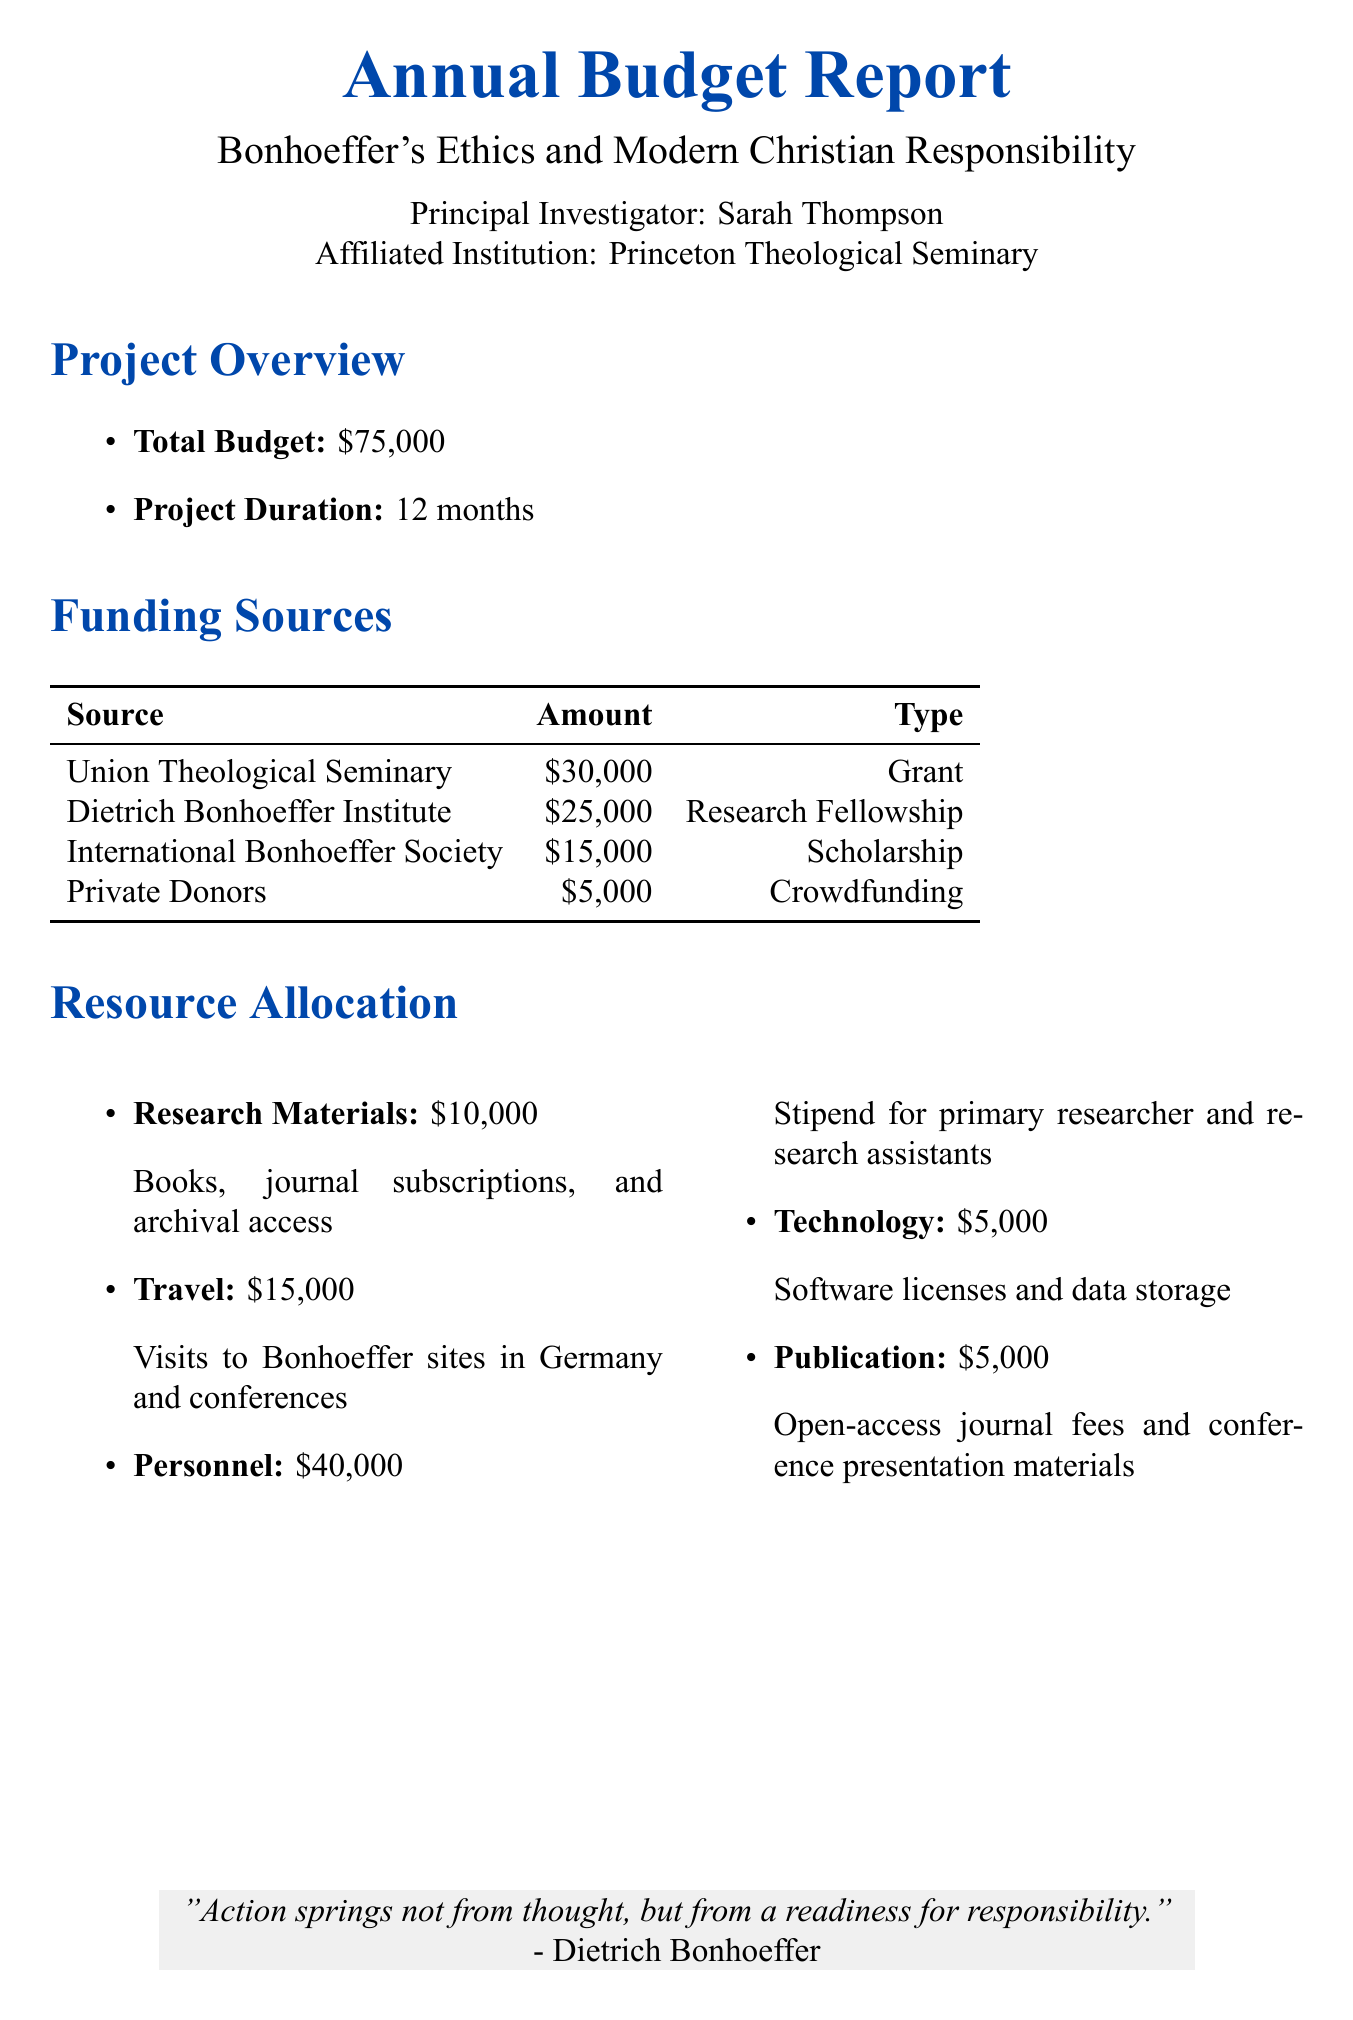What is the project title? The project title is explicitly mentioned in the document.
Answer: Bonhoeffer's Ethics and Modern Christian Responsibility Who is the principal investigator? The document states the name of the principal investigator associated with the project.
Answer: Sarah Thompson What is the total budget? The total budget is clearly outlined in the report.
Answer: $75,000 How much funding is received from the Dietrich Bonhoeffer Institute? The funding amount from each source is detailed in the funding section of the document.
Answer: $25,000 What category has the highest allocation of resources? The resource allocation section lists categories and their respective amounts, indicating which has the highest allocation.
Answer: Personnel How many months is the project duration? The project duration is specifically mentioned in the overview section of the document.
Answer: 12 months What type of funding does International Bonhoeffer Society provide? The type of funding for each source is outlined in the funding sources section of the document.
Answer: Scholarship What is the amount allocated for Travel? The amount for each resource category is provided in the resource allocation section.
Answer: $15,000 What percentage of the total budget is allocated to Research Materials? This requires calculating the ratio of the Research Materials allocation to the total budget, as given in the document.
Answer: 13.33% 